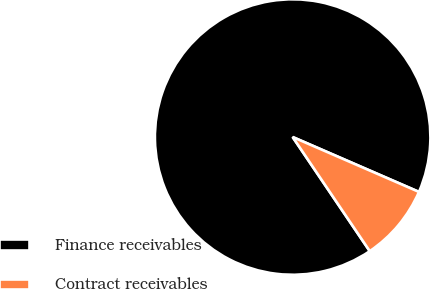<chart> <loc_0><loc_0><loc_500><loc_500><pie_chart><fcel>Finance receivables<fcel>Contract receivables<nl><fcel>90.98%<fcel>9.02%<nl></chart> 